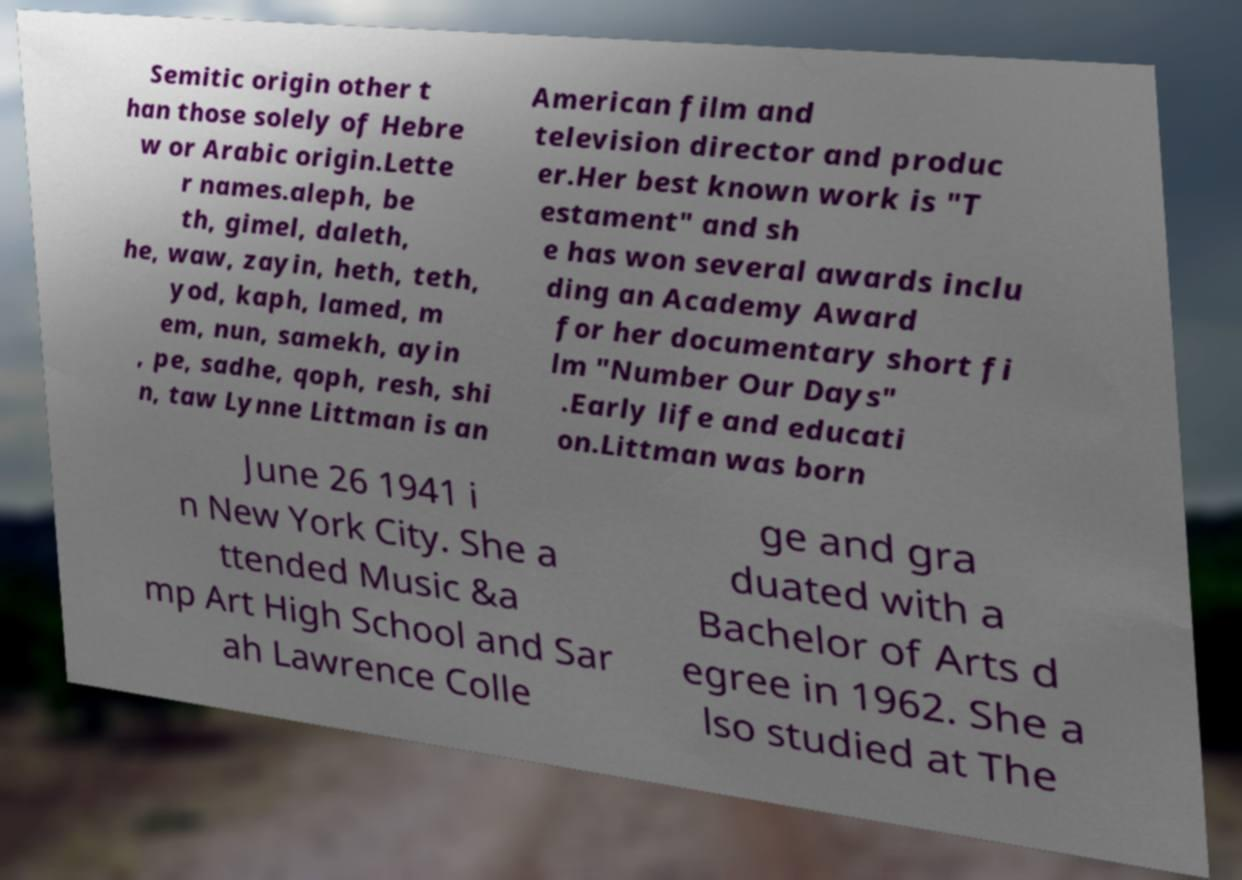Can you read and provide the text displayed in the image?This photo seems to have some interesting text. Can you extract and type it out for me? Semitic origin other t han those solely of Hebre w or Arabic origin.Lette r names.aleph, be th, gimel, daleth, he, waw, zayin, heth, teth, yod, kaph, lamed, m em, nun, samekh, ayin , pe, sadhe, qoph, resh, shi n, taw Lynne Littman is an American film and television director and produc er.Her best known work is "T estament" and sh e has won several awards inclu ding an Academy Award for her documentary short fi lm "Number Our Days" .Early life and educati on.Littman was born June 26 1941 i n New York City. She a ttended Music &a mp Art High School and Sar ah Lawrence Colle ge and gra duated with a Bachelor of Arts d egree in 1962. She a lso studied at The 